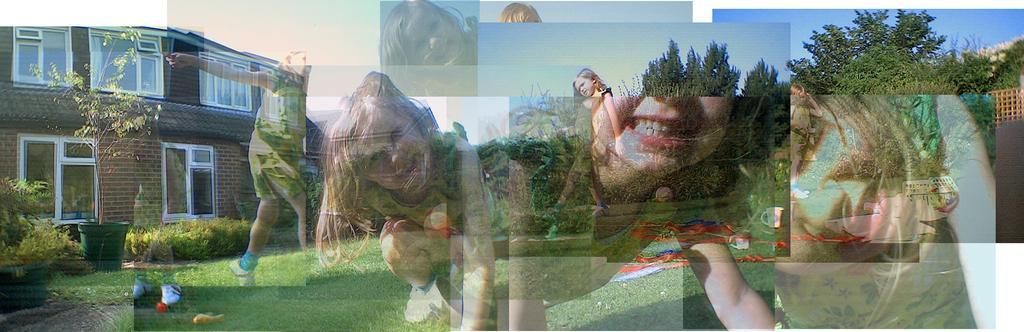Could you give a brief overview of what you see in this image? In this picture, it seems like a college, there are plants, a house, trees and the sky in the background. 